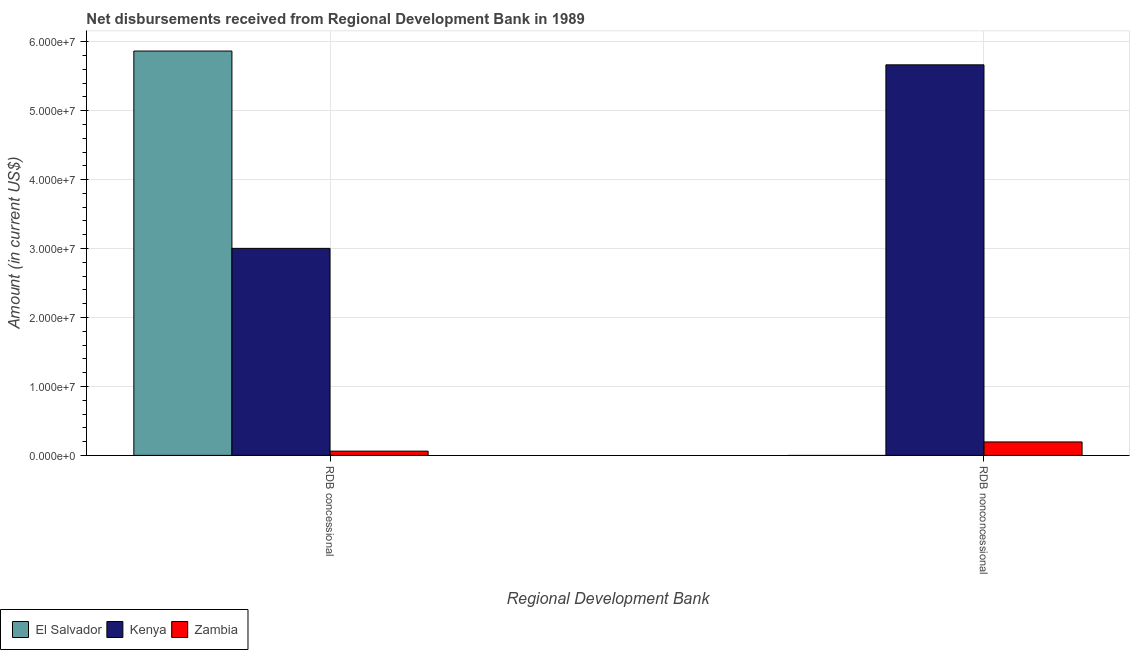Are the number of bars per tick equal to the number of legend labels?
Provide a succinct answer. No. What is the label of the 1st group of bars from the left?
Offer a very short reply. RDB concessional. What is the net concessional disbursements from rdb in Zambia?
Your answer should be compact. 6.18e+05. Across all countries, what is the maximum net concessional disbursements from rdb?
Your answer should be compact. 5.87e+07. In which country was the net concessional disbursements from rdb maximum?
Make the answer very short. El Salvador. What is the total net non concessional disbursements from rdb in the graph?
Offer a terse response. 5.86e+07. What is the difference between the net concessional disbursements from rdb in El Salvador and that in Kenya?
Your response must be concise. 2.86e+07. What is the difference between the net concessional disbursements from rdb in Kenya and the net non concessional disbursements from rdb in Zambia?
Offer a terse response. 2.81e+07. What is the average net non concessional disbursements from rdb per country?
Offer a terse response. 1.95e+07. What is the difference between the net non concessional disbursements from rdb and net concessional disbursements from rdb in Zambia?
Offer a very short reply. 1.33e+06. What is the ratio of the net concessional disbursements from rdb in El Salvador to that in Kenya?
Give a very brief answer. 1.95. In how many countries, is the net concessional disbursements from rdb greater than the average net concessional disbursements from rdb taken over all countries?
Ensure brevity in your answer.  2. How many bars are there?
Your answer should be very brief. 5. How many countries are there in the graph?
Your response must be concise. 3. What is the difference between two consecutive major ticks on the Y-axis?
Your response must be concise. 1.00e+07. Are the values on the major ticks of Y-axis written in scientific E-notation?
Your answer should be compact. Yes. Does the graph contain any zero values?
Give a very brief answer. Yes. Does the graph contain grids?
Your response must be concise. Yes. Where does the legend appear in the graph?
Provide a short and direct response. Bottom left. How many legend labels are there?
Your answer should be very brief. 3. What is the title of the graph?
Offer a terse response. Net disbursements received from Regional Development Bank in 1989. Does "Portugal" appear as one of the legend labels in the graph?
Offer a very short reply. No. What is the label or title of the X-axis?
Keep it short and to the point. Regional Development Bank. What is the Amount (in current US$) of El Salvador in RDB concessional?
Your answer should be very brief. 5.87e+07. What is the Amount (in current US$) in Kenya in RDB concessional?
Provide a short and direct response. 3.00e+07. What is the Amount (in current US$) in Zambia in RDB concessional?
Ensure brevity in your answer.  6.18e+05. What is the Amount (in current US$) of Kenya in RDB nonconcessional?
Offer a terse response. 5.67e+07. What is the Amount (in current US$) of Zambia in RDB nonconcessional?
Your response must be concise. 1.95e+06. Across all Regional Development Bank, what is the maximum Amount (in current US$) in El Salvador?
Keep it short and to the point. 5.87e+07. Across all Regional Development Bank, what is the maximum Amount (in current US$) in Kenya?
Ensure brevity in your answer.  5.67e+07. Across all Regional Development Bank, what is the maximum Amount (in current US$) in Zambia?
Offer a very short reply. 1.95e+06. Across all Regional Development Bank, what is the minimum Amount (in current US$) in El Salvador?
Your response must be concise. 0. Across all Regional Development Bank, what is the minimum Amount (in current US$) in Kenya?
Your answer should be very brief. 3.00e+07. Across all Regional Development Bank, what is the minimum Amount (in current US$) of Zambia?
Your answer should be compact. 6.18e+05. What is the total Amount (in current US$) of El Salvador in the graph?
Provide a short and direct response. 5.87e+07. What is the total Amount (in current US$) in Kenya in the graph?
Provide a short and direct response. 8.67e+07. What is the total Amount (in current US$) of Zambia in the graph?
Offer a terse response. 2.57e+06. What is the difference between the Amount (in current US$) in Kenya in RDB concessional and that in RDB nonconcessional?
Keep it short and to the point. -2.66e+07. What is the difference between the Amount (in current US$) in Zambia in RDB concessional and that in RDB nonconcessional?
Keep it short and to the point. -1.33e+06. What is the difference between the Amount (in current US$) of El Salvador in RDB concessional and the Amount (in current US$) of Zambia in RDB nonconcessional?
Keep it short and to the point. 5.67e+07. What is the difference between the Amount (in current US$) in Kenya in RDB concessional and the Amount (in current US$) in Zambia in RDB nonconcessional?
Ensure brevity in your answer.  2.81e+07. What is the average Amount (in current US$) of El Salvador per Regional Development Bank?
Provide a short and direct response. 2.93e+07. What is the average Amount (in current US$) of Kenya per Regional Development Bank?
Keep it short and to the point. 4.33e+07. What is the average Amount (in current US$) in Zambia per Regional Development Bank?
Provide a succinct answer. 1.28e+06. What is the difference between the Amount (in current US$) of El Salvador and Amount (in current US$) of Kenya in RDB concessional?
Make the answer very short. 2.86e+07. What is the difference between the Amount (in current US$) of El Salvador and Amount (in current US$) of Zambia in RDB concessional?
Keep it short and to the point. 5.80e+07. What is the difference between the Amount (in current US$) in Kenya and Amount (in current US$) in Zambia in RDB concessional?
Provide a short and direct response. 2.94e+07. What is the difference between the Amount (in current US$) of Kenya and Amount (in current US$) of Zambia in RDB nonconcessional?
Ensure brevity in your answer.  5.47e+07. What is the ratio of the Amount (in current US$) in Kenya in RDB concessional to that in RDB nonconcessional?
Offer a terse response. 0.53. What is the ratio of the Amount (in current US$) of Zambia in RDB concessional to that in RDB nonconcessional?
Your answer should be compact. 0.32. What is the difference between the highest and the second highest Amount (in current US$) in Kenya?
Your answer should be very brief. 2.66e+07. What is the difference between the highest and the second highest Amount (in current US$) of Zambia?
Your answer should be very brief. 1.33e+06. What is the difference between the highest and the lowest Amount (in current US$) in El Salvador?
Provide a succinct answer. 5.87e+07. What is the difference between the highest and the lowest Amount (in current US$) of Kenya?
Provide a succinct answer. 2.66e+07. What is the difference between the highest and the lowest Amount (in current US$) of Zambia?
Provide a succinct answer. 1.33e+06. 